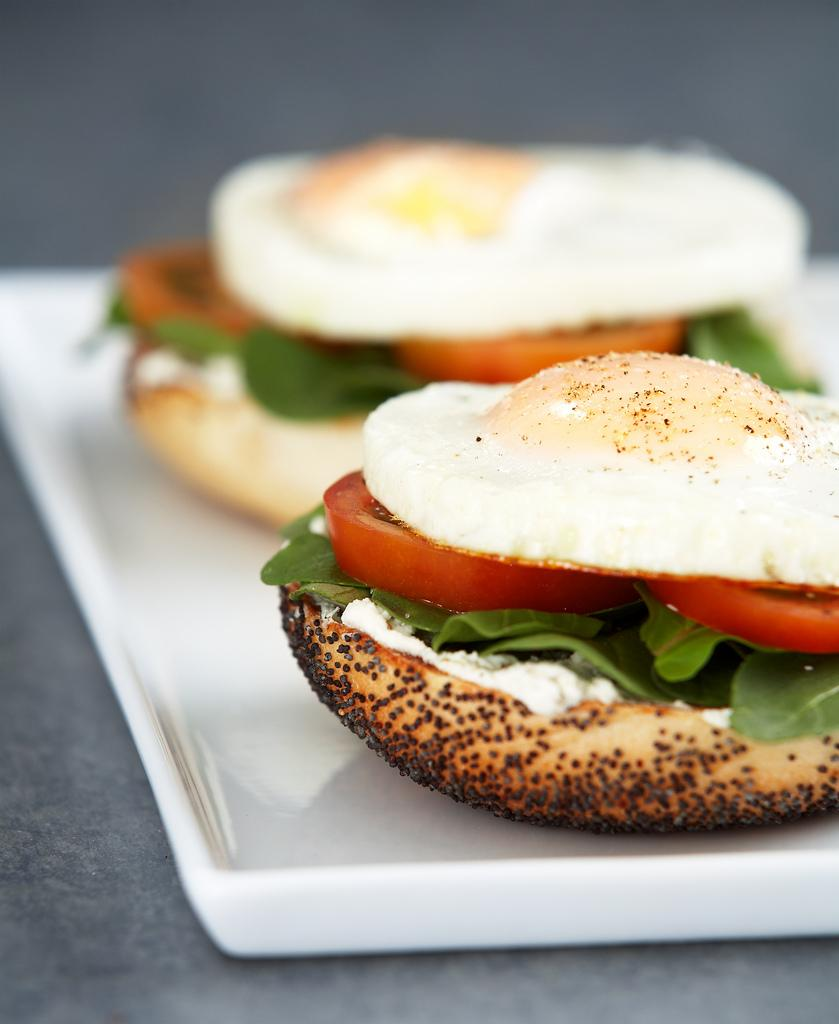What type of food can be seen in the image? There are two burgers on a platter in the image. Where are the burgers located in relation to the image? The burgers are in the foreground of the image. What class is being taught in the image? There is no class or teaching activity depicted in the image; it features two burgers on a platter. How much waste is generated by the burgers in the image? There is no information about waste generation in the image, as it only shows two burgers on a platter. 